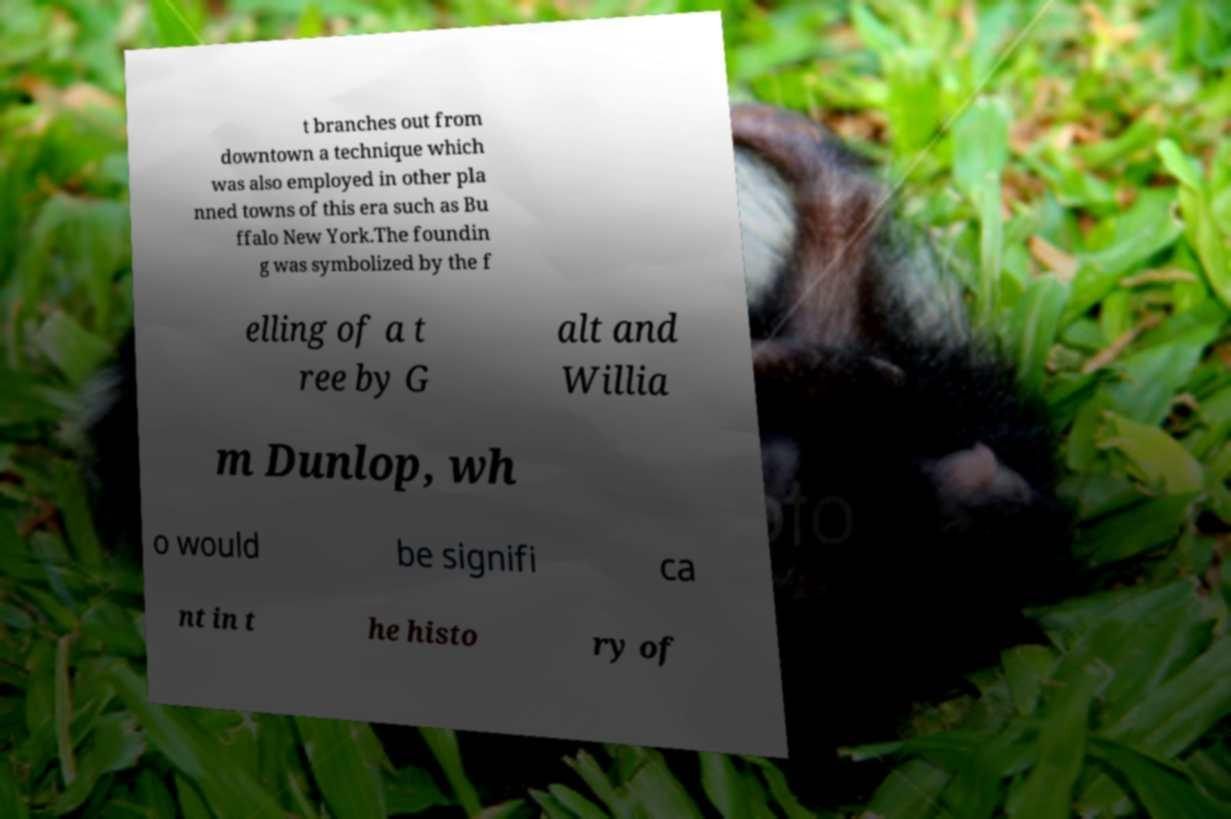Can you read and provide the text displayed in the image?This photo seems to have some interesting text. Can you extract and type it out for me? t branches out from downtown a technique which was also employed in other pla nned towns of this era such as Bu ffalo New York.The foundin g was symbolized by the f elling of a t ree by G alt and Willia m Dunlop, wh o would be signifi ca nt in t he histo ry of 